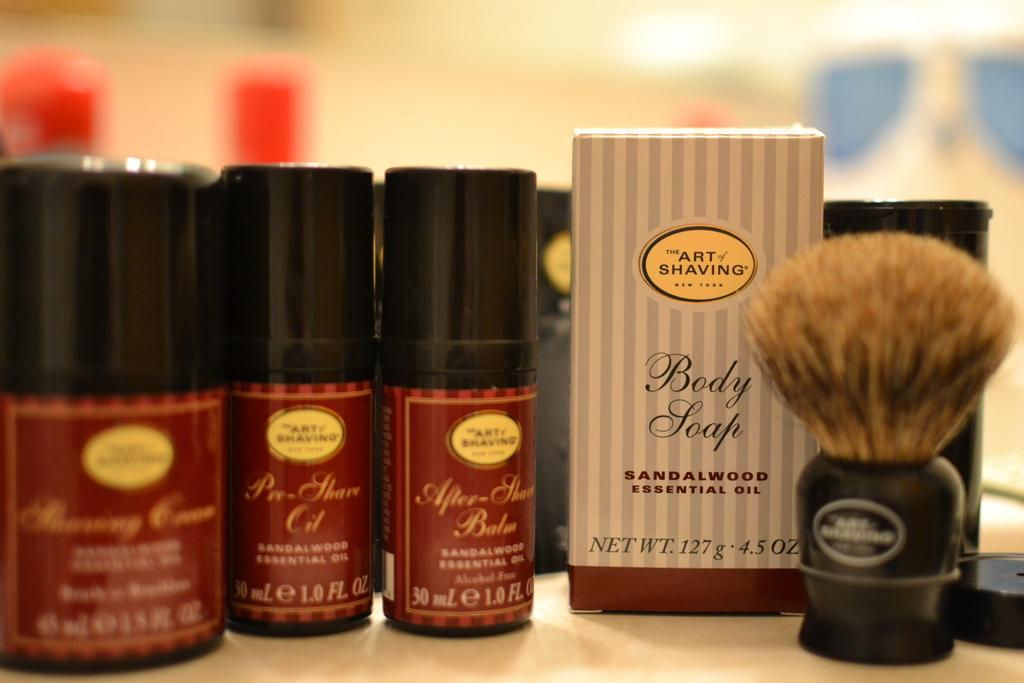<image>
Give a short and clear explanation of the subsequent image. Products from the brand "The Art of Shaving" are lined up neatly on a countertop. 